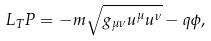<formula> <loc_0><loc_0><loc_500><loc_500>L _ { T } P = - m \sqrt { g _ { \mu \nu } u ^ { \mu } u ^ { \nu } } - q \phi ,</formula> 